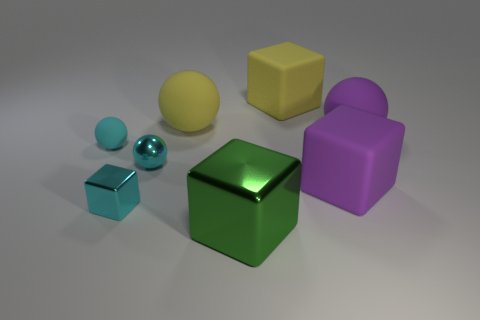Is the number of green metal cubes that are in front of the green metallic thing greater than the number of small cyan cubes? After examining the image, it's apparent that there are no green metal cubes in front of the green metallic cube; in fact, there is only one green metal cube present. There is one small cyan cube visible in the image. Therefore, the statement that the number of green metal cubes in front of the green metallic thing is greater than the number of small cyan cubes is incorrect. 